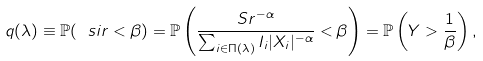Convert formula to latex. <formula><loc_0><loc_0><loc_500><loc_500>q ( \lambda ) \equiv \mathbb { P } ( \ s i r < \beta ) = \mathbb { P } \left ( \frac { S r ^ { - \alpha } } { \sum _ { i \in \Pi ( \lambda ) } I _ { i } | X _ { i } | ^ { - \alpha } } < \beta \right ) = \mathbb { P } \left ( Y > \frac { 1 } { \beta } \right ) ,</formula> 